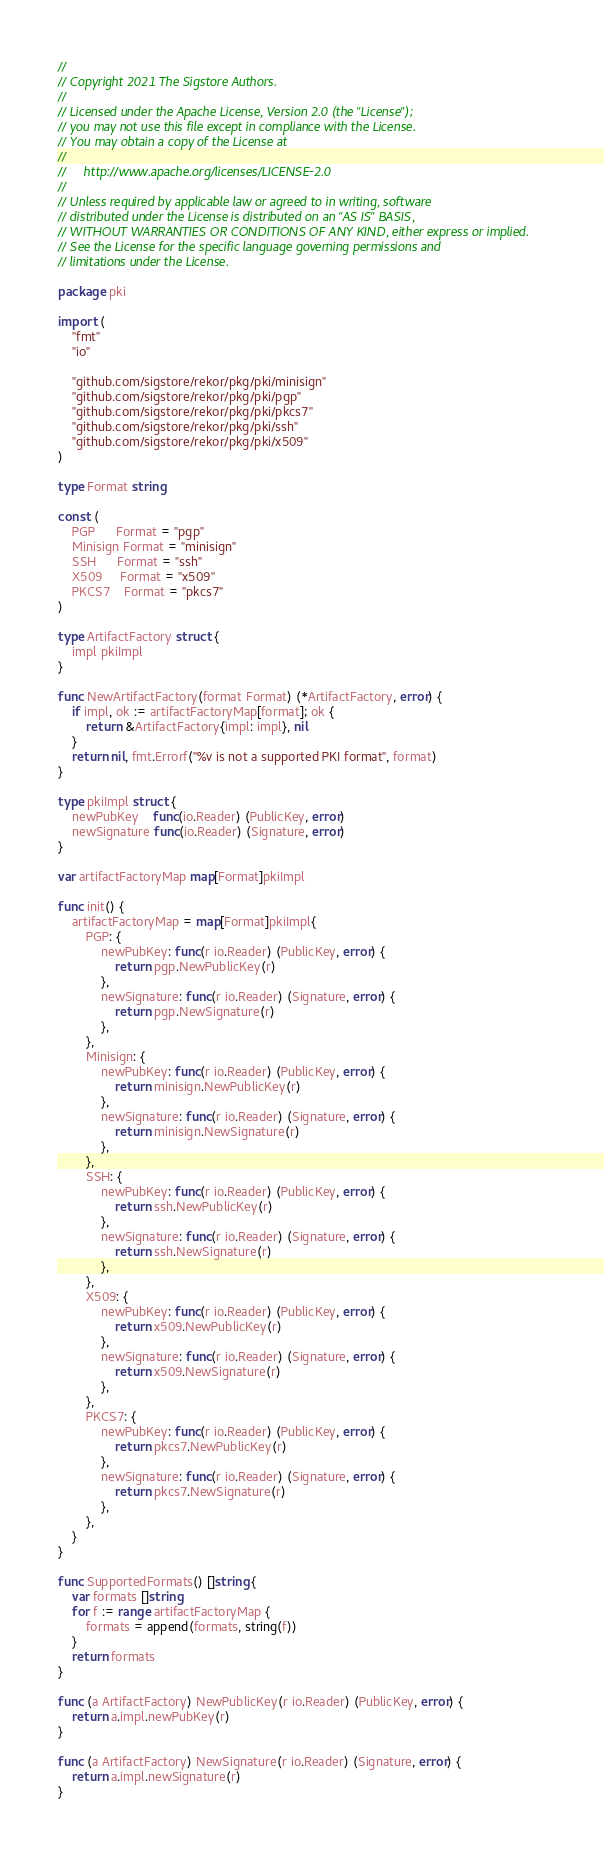<code> <loc_0><loc_0><loc_500><loc_500><_Go_>//
// Copyright 2021 The Sigstore Authors.
//
// Licensed under the Apache License, Version 2.0 (the "License");
// you may not use this file except in compliance with the License.
// You may obtain a copy of the License at
//
//     http://www.apache.org/licenses/LICENSE-2.0
//
// Unless required by applicable law or agreed to in writing, software
// distributed under the License is distributed on an "AS IS" BASIS,
// WITHOUT WARRANTIES OR CONDITIONS OF ANY KIND, either express or implied.
// See the License for the specific language governing permissions and
// limitations under the License.

package pki

import (
	"fmt"
	"io"

	"github.com/sigstore/rekor/pkg/pki/minisign"
	"github.com/sigstore/rekor/pkg/pki/pgp"
	"github.com/sigstore/rekor/pkg/pki/pkcs7"
	"github.com/sigstore/rekor/pkg/pki/ssh"
	"github.com/sigstore/rekor/pkg/pki/x509"
)

type Format string

const (
	PGP      Format = "pgp"
	Minisign Format = "minisign"
	SSH      Format = "ssh"
	X509     Format = "x509"
	PKCS7    Format = "pkcs7"
)

type ArtifactFactory struct {
	impl pkiImpl
}

func NewArtifactFactory(format Format) (*ArtifactFactory, error) {
	if impl, ok := artifactFactoryMap[format]; ok {
		return &ArtifactFactory{impl: impl}, nil
	}
	return nil, fmt.Errorf("%v is not a supported PKI format", format)
}

type pkiImpl struct {
	newPubKey    func(io.Reader) (PublicKey, error)
	newSignature func(io.Reader) (Signature, error)
}

var artifactFactoryMap map[Format]pkiImpl

func init() {
	artifactFactoryMap = map[Format]pkiImpl{
		PGP: {
			newPubKey: func(r io.Reader) (PublicKey, error) {
				return pgp.NewPublicKey(r)
			},
			newSignature: func(r io.Reader) (Signature, error) {
				return pgp.NewSignature(r)
			},
		},
		Minisign: {
			newPubKey: func(r io.Reader) (PublicKey, error) {
				return minisign.NewPublicKey(r)
			},
			newSignature: func(r io.Reader) (Signature, error) {
				return minisign.NewSignature(r)
			},
		},
		SSH: {
			newPubKey: func(r io.Reader) (PublicKey, error) {
				return ssh.NewPublicKey(r)
			},
			newSignature: func(r io.Reader) (Signature, error) {
				return ssh.NewSignature(r)
			},
		},
		X509: {
			newPubKey: func(r io.Reader) (PublicKey, error) {
				return x509.NewPublicKey(r)
			},
			newSignature: func(r io.Reader) (Signature, error) {
				return x509.NewSignature(r)
			},
		},
		PKCS7: {
			newPubKey: func(r io.Reader) (PublicKey, error) {
				return pkcs7.NewPublicKey(r)
			},
			newSignature: func(r io.Reader) (Signature, error) {
				return pkcs7.NewSignature(r)
			},
		},
	}
}

func SupportedFormats() []string {
	var formats []string
	for f := range artifactFactoryMap {
		formats = append(formats, string(f))
	}
	return formats
}

func (a ArtifactFactory) NewPublicKey(r io.Reader) (PublicKey, error) {
	return a.impl.newPubKey(r)
}

func (a ArtifactFactory) NewSignature(r io.Reader) (Signature, error) {
	return a.impl.newSignature(r)
}
</code> 